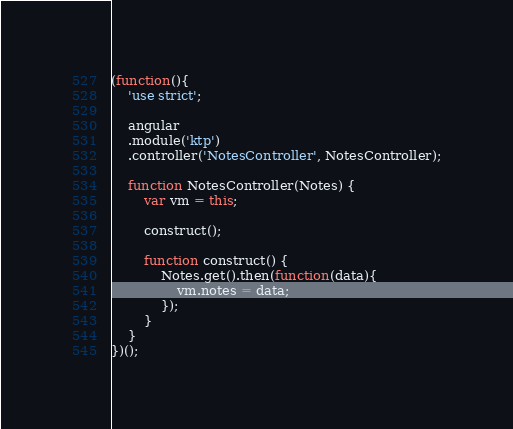<code> <loc_0><loc_0><loc_500><loc_500><_JavaScript_>(function(){
    'use strict';

    angular
    .module('ktp')
    .controller('NotesController', NotesController);

    function NotesController(Notes) {
        var vm = this;

        construct();

        function construct() {
            Notes.get().then(function(data){
                vm.notes = data;
            });
        }
    }
})();
</code> 